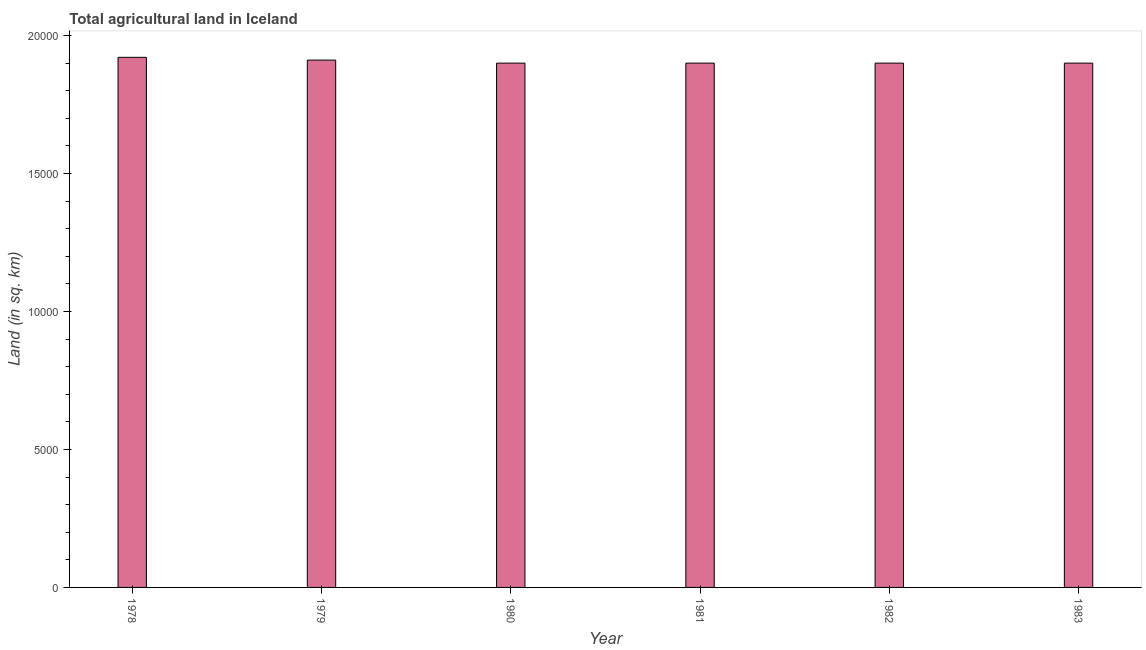Does the graph contain grids?
Your answer should be very brief. No. What is the title of the graph?
Make the answer very short. Total agricultural land in Iceland. What is the label or title of the X-axis?
Give a very brief answer. Year. What is the label or title of the Y-axis?
Your response must be concise. Land (in sq. km). What is the agricultural land in 1981?
Offer a very short reply. 1.90e+04. Across all years, what is the maximum agricultural land?
Your answer should be very brief. 1.92e+04. Across all years, what is the minimum agricultural land?
Keep it short and to the point. 1.90e+04. In which year was the agricultural land maximum?
Keep it short and to the point. 1978. In which year was the agricultural land minimum?
Give a very brief answer. 1980. What is the sum of the agricultural land?
Provide a succinct answer. 1.14e+05. What is the difference between the agricultural land in 1978 and 1979?
Your answer should be compact. 100. What is the average agricultural land per year?
Ensure brevity in your answer.  1.91e+04. What is the median agricultural land?
Ensure brevity in your answer.  1.90e+04. In how many years, is the agricultural land greater than 7000 sq. km?
Offer a very short reply. 6. Do a majority of the years between 1979 and 1980 (inclusive) have agricultural land greater than 15000 sq. km?
Provide a short and direct response. Yes. Is the agricultural land in 1978 less than that in 1979?
Give a very brief answer. No. What is the difference between the highest and the second highest agricultural land?
Provide a short and direct response. 100. Is the sum of the agricultural land in 1980 and 1983 greater than the maximum agricultural land across all years?
Keep it short and to the point. Yes. What is the difference between the highest and the lowest agricultural land?
Keep it short and to the point. 210. In how many years, is the agricultural land greater than the average agricultural land taken over all years?
Your answer should be very brief. 2. Are all the bars in the graph horizontal?
Offer a terse response. No. How many years are there in the graph?
Give a very brief answer. 6. Are the values on the major ticks of Y-axis written in scientific E-notation?
Make the answer very short. No. What is the Land (in sq. km) in 1978?
Give a very brief answer. 1.92e+04. What is the Land (in sq. km) in 1979?
Give a very brief answer. 1.91e+04. What is the Land (in sq. km) of 1980?
Keep it short and to the point. 1.90e+04. What is the Land (in sq. km) in 1981?
Your answer should be compact. 1.90e+04. What is the Land (in sq. km) of 1982?
Keep it short and to the point. 1.90e+04. What is the Land (in sq. km) in 1983?
Offer a very short reply. 1.90e+04. What is the difference between the Land (in sq. km) in 1978 and 1980?
Give a very brief answer. 210. What is the difference between the Land (in sq. km) in 1978 and 1981?
Your answer should be compact. 210. What is the difference between the Land (in sq. km) in 1978 and 1982?
Provide a succinct answer. 210. What is the difference between the Land (in sq. km) in 1978 and 1983?
Provide a short and direct response. 210. What is the difference between the Land (in sq. km) in 1979 and 1980?
Keep it short and to the point. 110. What is the difference between the Land (in sq. km) in 1979 and 1981?
Offer a very short reply. 110. What is the difference between the Land (in sq. km) in 1979 and 1982?
Give a very brief answer. 110. What is the difference between the Land (in sq. km) in 1979 and 1983?
Your answer should be compact. 110. What is the difference between the Land (in sq. km) in 1980 and 1982?
Make the answer very short. 0. What is the difference between the Land (in sq. km) in 1980 and 1983?
Offer a terse response. 0. What is the difference between the Land (in sq. km) in 1981 and 1983?
Your answer should be compact. 0. What is the ratio of the Land (in sq. km) in 1978 to that in 1979?
Provide a short and direct response. 1. What is the ratio of the Land (in sq. km) in 1978 to that in 1980?
Give a very brief answer. 1.01. What is the ratio of the Land (in sq. km) in 1978 to that in 1981?
Your answer should be compact. 1.01. What is the ratio of the Land (in sq. km) in 1978 to that in 1983?
Offer a very short reply. 1.01. What is the ratio of the Land (in sq. km) in 1979 to that in 1980?
Ensure brevity in your answer.  1.01. What is the ratio of the Land (in sq. km) in 1979 to that in 1983?
Keep it short and to the point. 1.01. What is the ratio of the Land (in sq. km) in 1980 to that in 1981?
Provide a succinct answer. 1. What is the ratio of the Land (in sq. km) in 1980 to that in 1982?
Give a very brief answer. 1. 